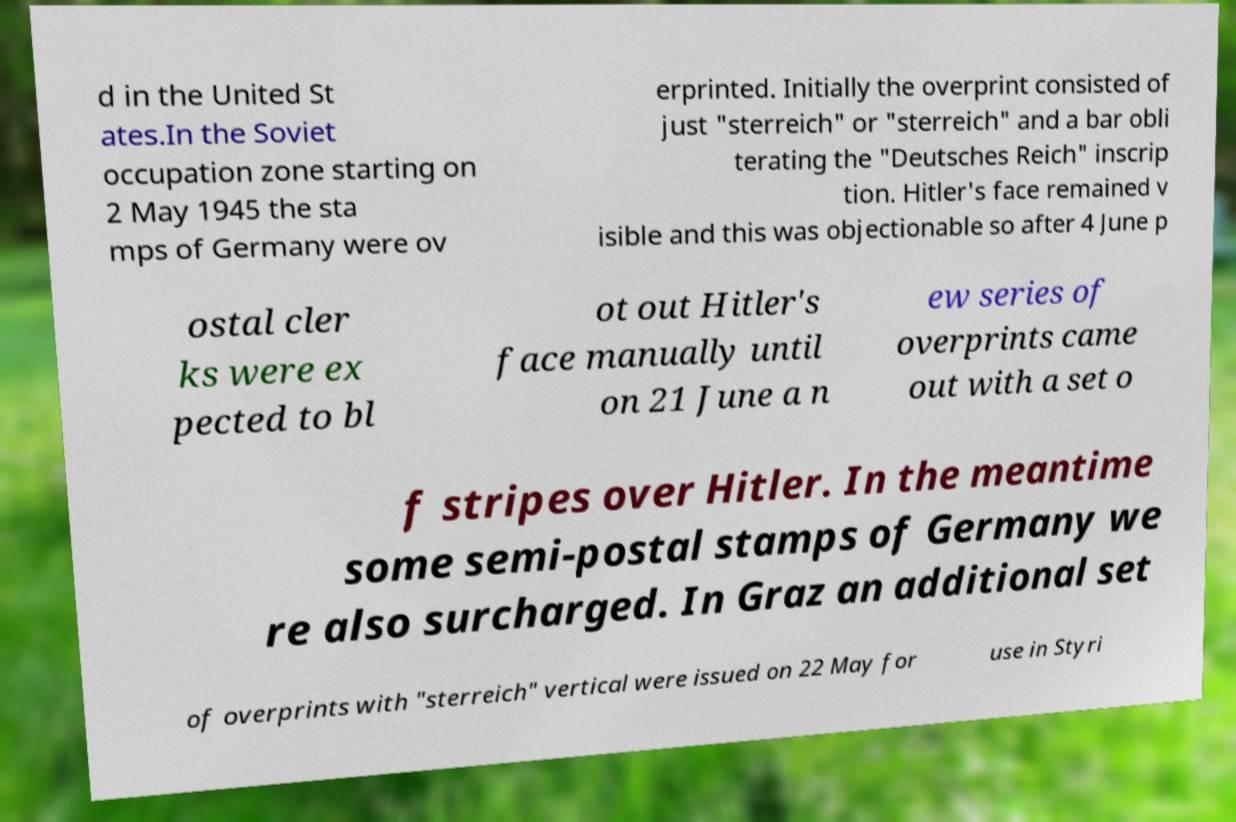For documentation purposes, I need the text within this image transcribed. Could you provide that? d in the United St ates.In the Soviet occupation zone starting on 2 May 1945 the sta mps of Germany were ov erprinted. Initially the overprint consisted of just "sterreich" or "sterreich" and a bar obli terating the "Deutsches Reich" inscrip tion. Hitler's face remained v isible and this was objectionable so after 4 June p ostal cler ks were ex pected to bl ot out Hitler's face manually until on 21 June a n ew series of overprints came out with a set o f stripes over Hitler. In the meantime some semi-postal stamps of Germany we re also surcharged. In Graz an additional set of overprints with "sterreich" vertical were issued on 22 May for use in Styri 